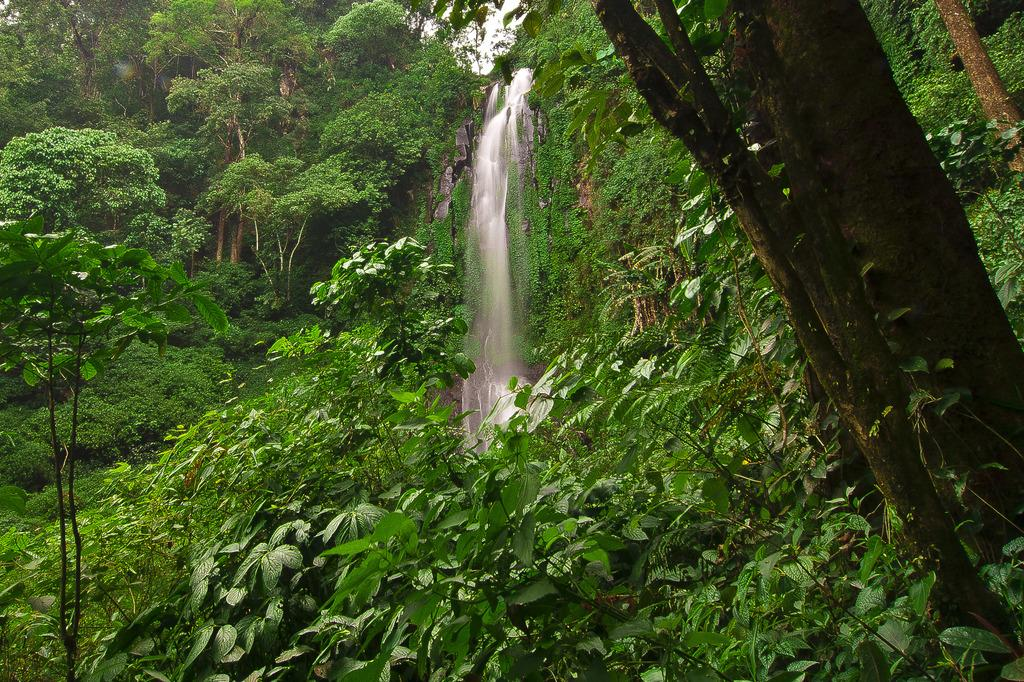What type of environment might the image be set in? The image might be taken in a forest. What is the main feature in the center of the image? There is a waterfall in the center of the image. What can be seen in the foreground of the image? There are trees in the foreground of the image. What can be seen in the background of the image? There are trees in the background of the image. Is there a beggar asking for money near the waterfall in the image? There is no beggar present in the image; it features a waterfall in a forest setting. What type of pest is causing problems for the trees in the image? There is no indication of any pests affecting the trees in the image; it simply shows trees in a forest setting. 